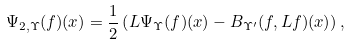Convert formula to latex. <formula><loc_0><loc_0><loc_500><loc_500>\Psi _ { 2 , \Upsilon } ( f ) ( x ) = \frac { 1 } { 2 } \left ( L \Psi _ { \Upsilon } ( f ) ( x ) - B _ { \Upsilon ^ { \prime } } ( f , L f ) ( x ) \right ) ,</formula> 